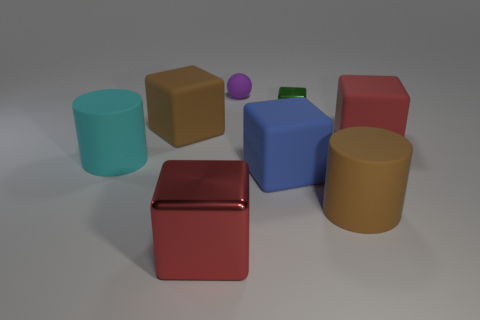There is a thing that is the same color as the big metal cube; what material is it?
Offer a terse response. Rubber. Is the green shiny object the same shape as the big cyan thing?
Offer a terse response. No. How many other things are there of the same color as the large metallic object?
Make the answer very short. 1. There is a big metallic thing; does it have the same color as the rubber block that is right of the blue rubber thing?
Your response must be concise. Yes. How many green metal objects are the same shape as the small matte object?
Offer a very short reply. 0. There is a red block that is behind the large cylinder that is on the right side of the red shiny cube; how big is it?
Your answer should be very brief. Large. Do the cylinder that is in front of the big cyan object and the matte cube on the left side of the tiny rubber ball have the same color?
Your answer should be compact. Yes. There is a large matte block that is in front of the large block on the right side of the blue rubber cube; what number of brown rubber cylinders are left of it?
Give a very brief answer. 0. What number of objects are in front of the tiny ball and behind the blue matte block?
Offer a terse response. 4. Are there more large cubes that are to the right of the big brown block than gray matte cylinders?
Your response must be concise. Yes. 